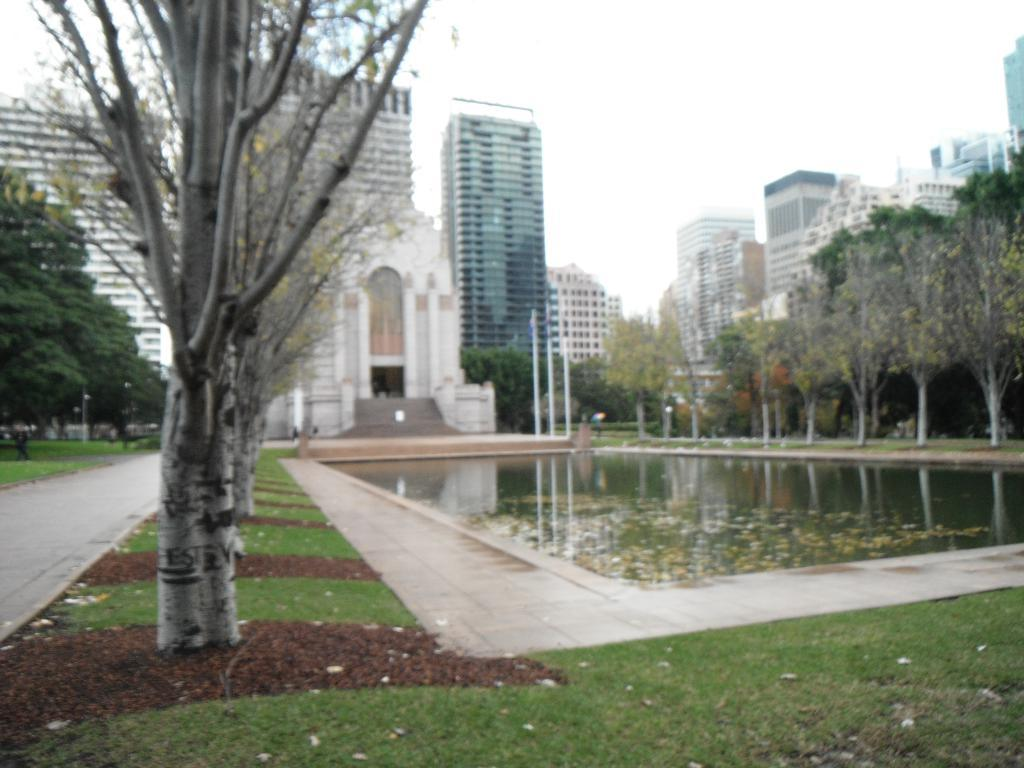What is one of the natural elements present in the image? There is water in the image. What type of vegetation can be seen in the image? There are trees in the image. What are the poles used for in the image? The purpose of the poles is not specified, but they are visible in the image. What type of ground surface is present in the image? There is grass in the image. What type of man-made structures are present in the image? There are buildings in the image. What can be seen in the background of the image? The sky is visible in the background of the image. What type of grape is being used as a reward for the space explorer in the image? There is no grape or space explorer present in the image. 